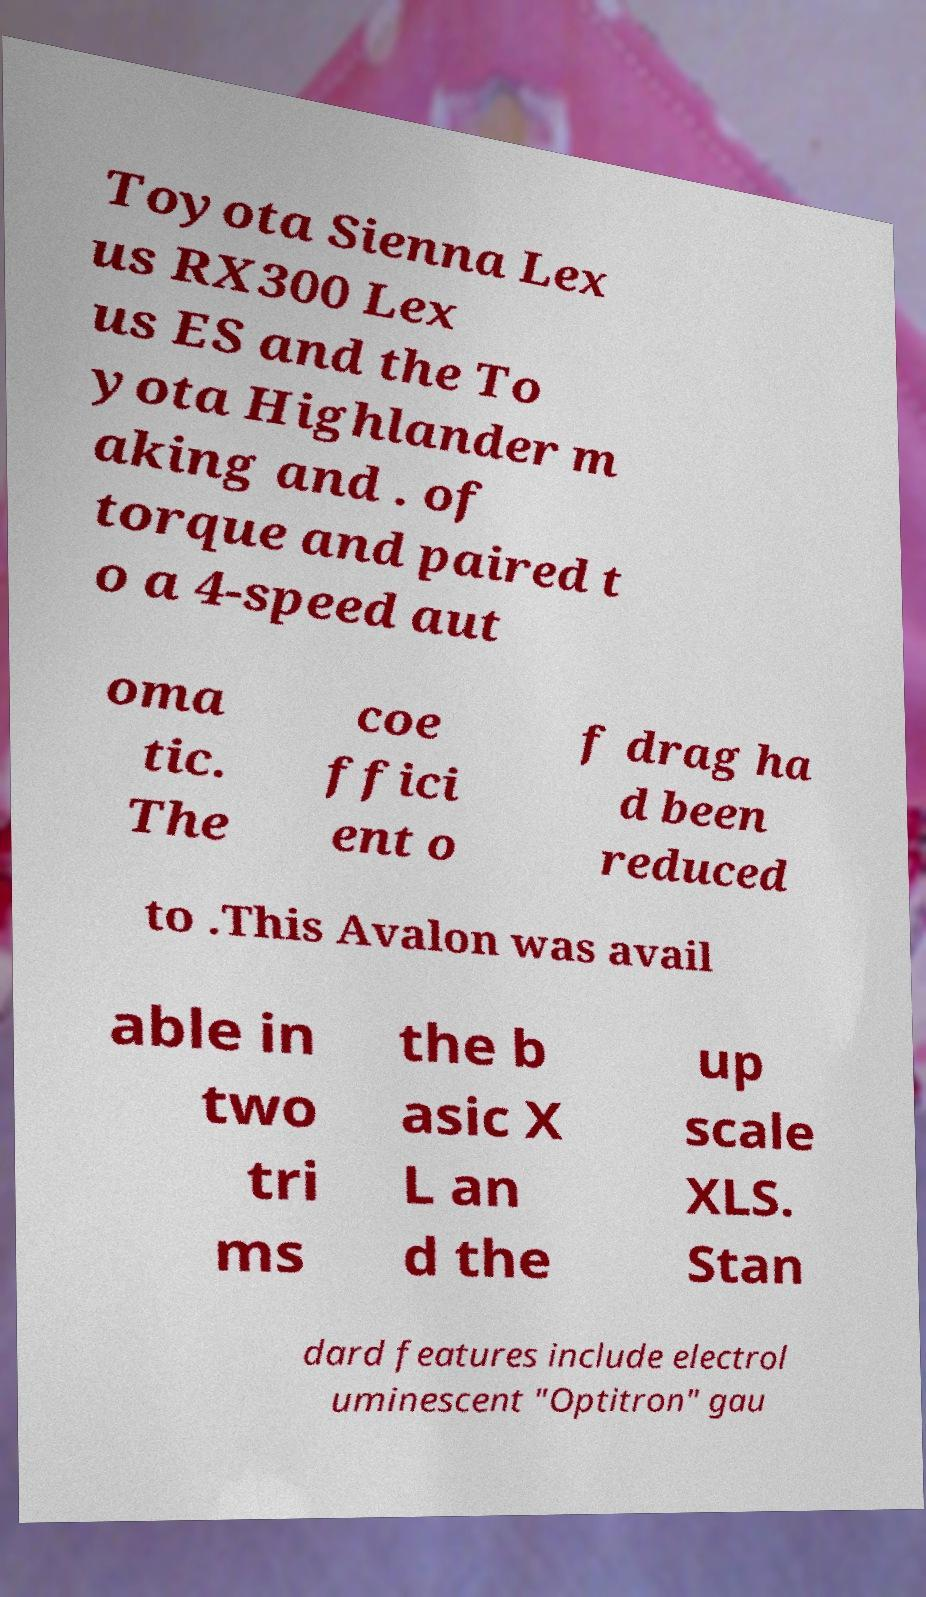There's text embedded in this image that I need extracted. Can you transcribe it verbatim? Toyota Sienna Lex us RX300 Lex us ES and the To yota Highlander m aking and . of torque and paired t o a 4-speed aut oma tic. The coe ffici ent o f drag ha d been reduced to .This Avalon was avail able in two tri ms the b asic X L an d the up scale XLS. Stan dard features include electrol uminescent "Optitron" gau 